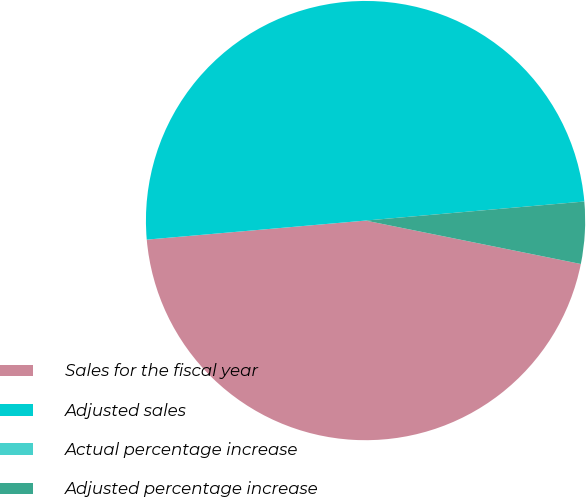Convert chart. <chart><loc_0><loc_0><loc_500><loc_500><pie_chart><fcel>Sales for the fiscal year<fcel>Adjusted sales<fcel>Actual percentage increase<fcel>Adjusted percentage increase<nl><fcel>45.45%<fcel>50.0%<fcel>0.0%<fcel>4.55%<nl></chart> 